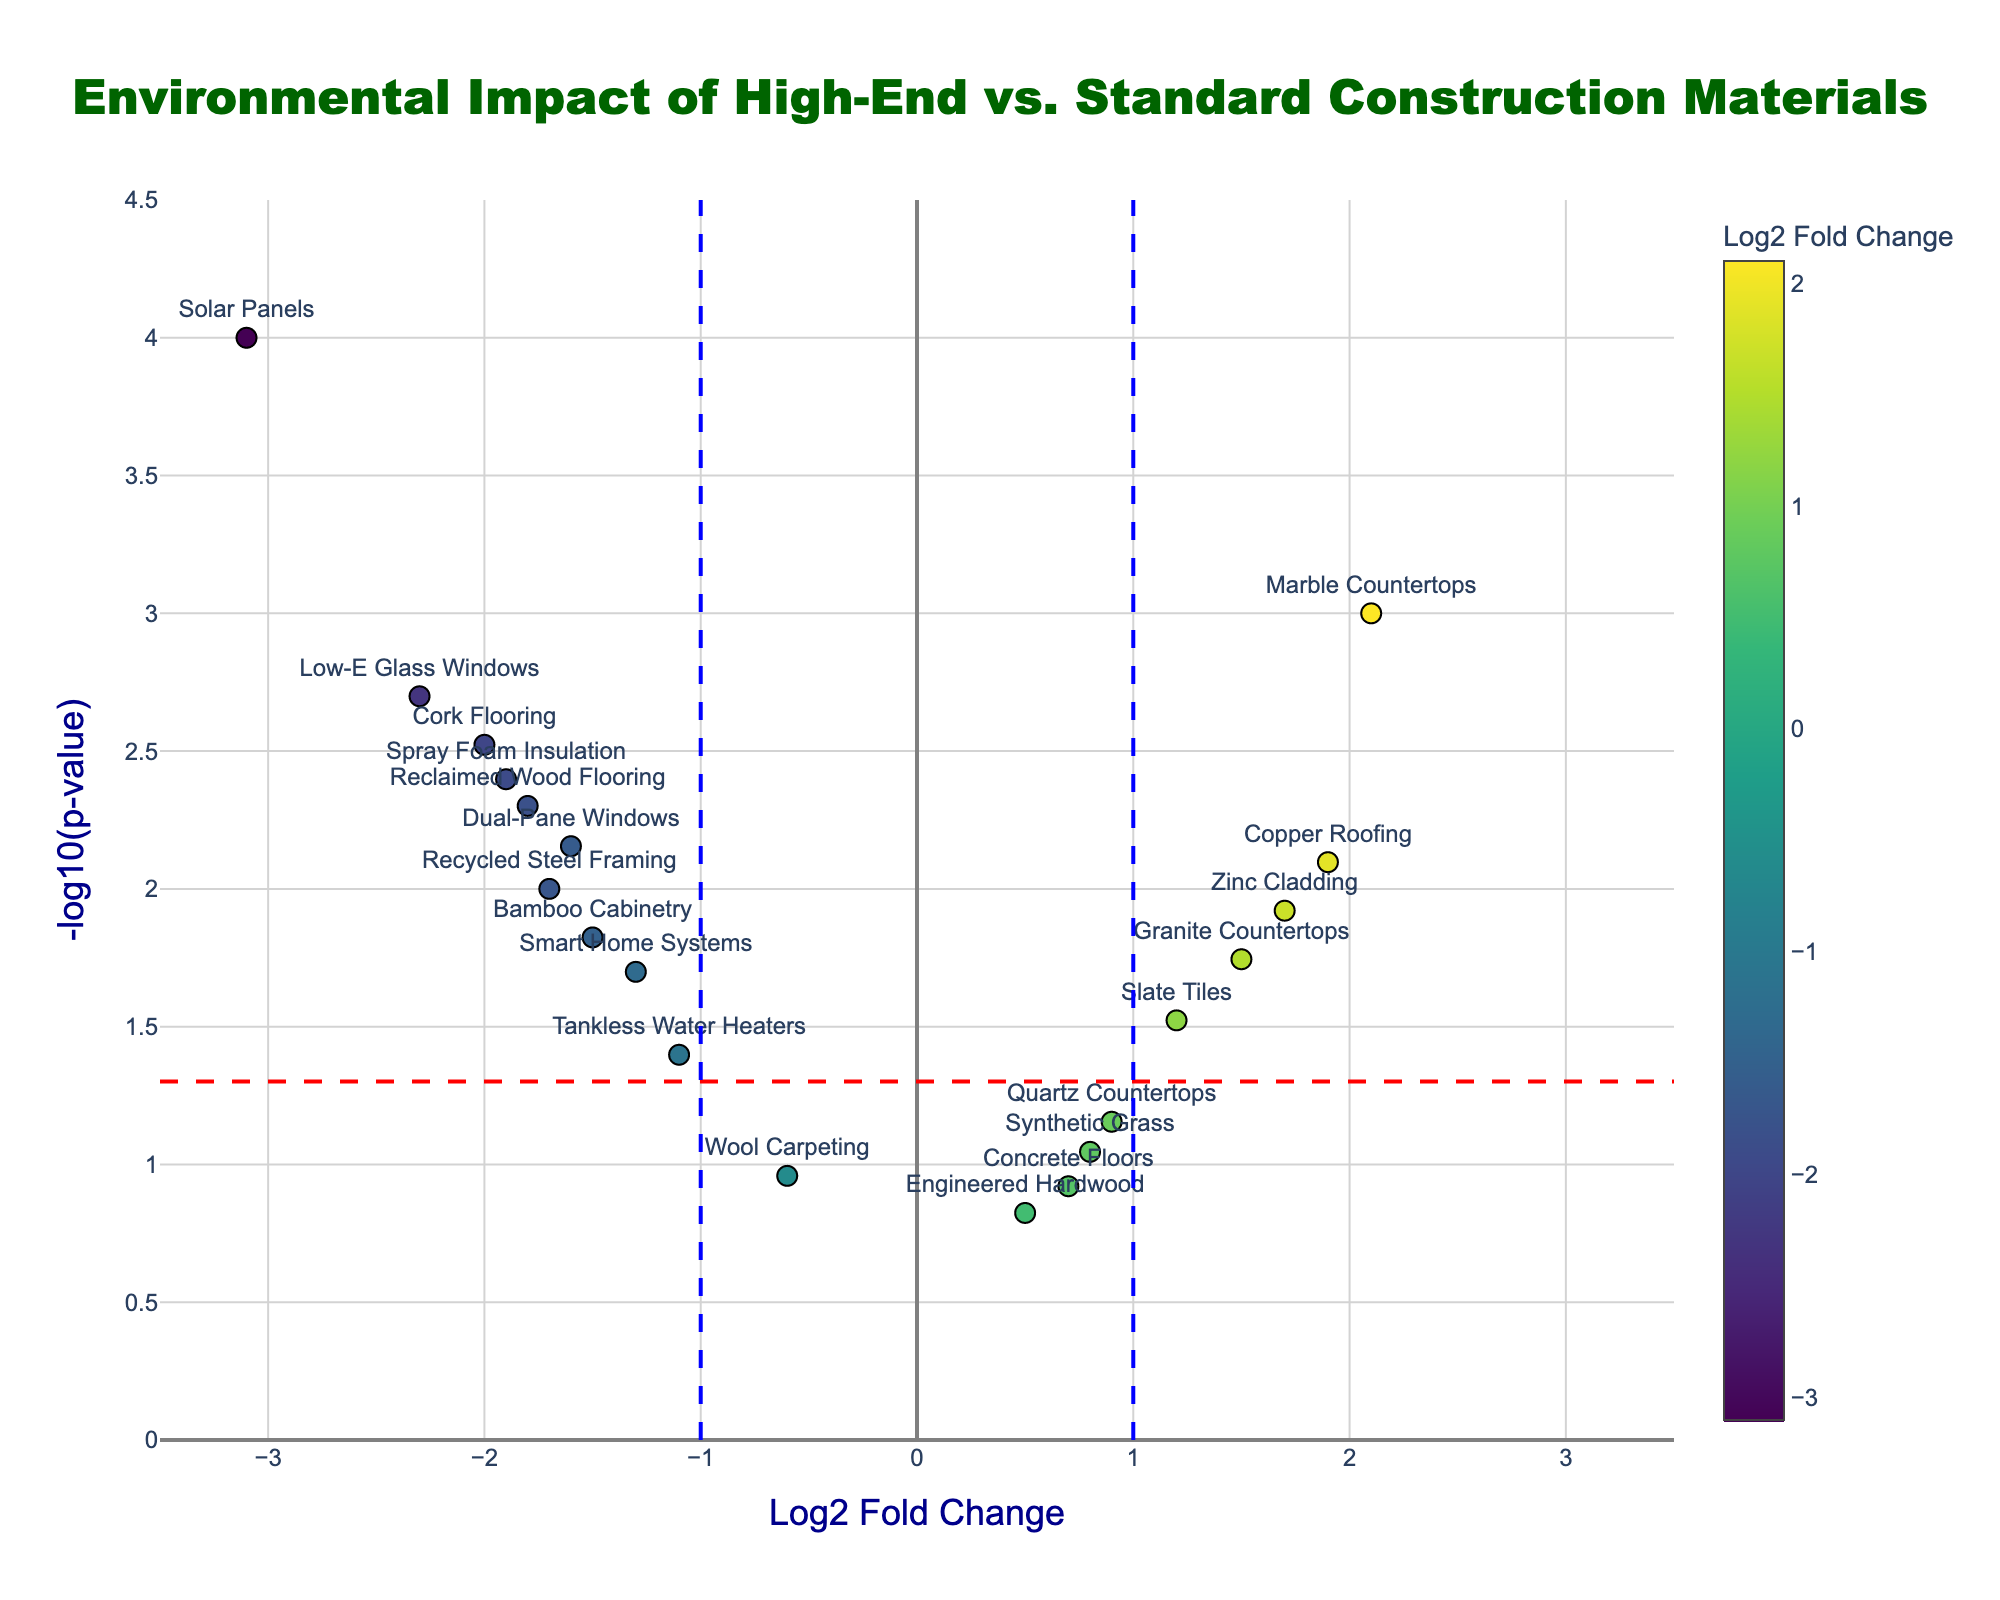What is the title of the figure? The title is typically displayed at the top of the figure. In this case, it is "Environmental Impact of High-End vs. Standard Construction Materials".
Answer: Environmental Impact of High-End vs. Standard Construction Materials What are the axes labels? The x-axis label is "Log2 Fold Change" and the y-axis label is "-log10(p-value)". These labels are located beside the respective axes and provide information on what each axis represents.
Answer: Log2 Fold Change and -log10(p-value) How many materials have a positive Log2 Fold Change? To find the number of materials with a positive Log2 Fold Change, count the points on the right side of the y-axis where the x-values are greater than 0.
Answer: 7 Which material has the most negative Log2 Fold Change and what is its value? Locate the material on the far left of the x-axis to find the most negative Log2 Fold Change. The material is "Solar Panels" and the Log2 Fold Change value is -3.1.
Answer: Solar Panels with a value of -3.1 Which materials are considered significant at the 0.05 level? Materials are considered significant if their p-value is less than 0.05. This means their -log10(p) is above the horizontal red dashed line. The significant materials include "Marble Countertops", "Reclaimed Wood Flooring", "Low-E Glass Windows", "Copper Roofing", "Bamboo Cabinetry", "Slate Tiles", "Solar Panels", "Recycled Steel Framing", "Cork Flooring", "Smart Home Systems", "Granite Countertops", "Tankless Water Heaters", "Dual-Pane Windows", "Spray Foam Insulation", and "Zinc Cladding".
Answer: 15 materials Which materials are above the significance threshold but have Log2 Fold Change values between -1 and 1? Identify the points above the horizontal red dashed line (significance threshold) and between the vertical blue dashed lines (-1 and 1 on x-axis). These materials are "Slate Tiles", "Quartz Countertops", "Synthetic Grass", and "Engineered Hardwood".
Answer: 4 materials Which material has the highest -log10(p-value) and what is this value? Look for the point highest on the y-axis to determine the material with the highest -log10(p-value). "Solar Panels" sits the highest with a value of roughly 4.0.
Answer: Solar Panels with a value of 4.0 How many materials have a Log2 Fold Change greater than 1? Count the number of points to the right of the vertical blue dashed line at 1 on the x-axis. Materials include "Marble Countertops", "Copper Roofing", "Granite Countertops", and "Zinc Cladding".
Answer: 4 materials What is the approximate range of p-values represented in the figure? Convert the highest and lowest -log10(p-values) back to p-values. The range on the y-axis is approximately 0 to 4.5, translating to p-values from 1 to 10^-4.5.
Answer: From 1 to 0.00003 